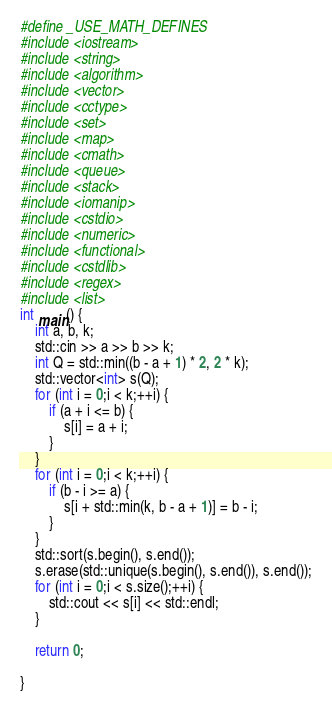Convert code to text. <code><loc_0><loc_0><loc_500><loc_500><_C++_>#define _USE_MATH_DEFINES
#include <iostream>
#include <string>
#include <algorithm>
#include <vector>
#include <cctype>
#include <set>
#include <map>
#include <cmath>
#include <queue>
#include <stack>
#include <iomanip>
#include <cstdio>
#include <numeric>
#include <functional>
#include <cstdlib>
#include <regex>
#include <list>
int main() {
	int a, b, k;
	std::cin >> a >> b >> k;
	int Q = std::min((b - a + 1) * 2, 2 * k);
	std::vector<int> s(Q);
	for (int i = 0;i < k;++i) {
		if (a + i <= b) {
			s[i] = a + i;
		}
	}
	for (int i = 0;i < k;++i) {
		if (b - i >= a) {
			s[i + std::min(k, b - a + 1)] = b - i;
		}
	}
	std::sort(s.begin(), s.end());
	s.erase(std::unique(s.begin(), s.end()), s.end());
	for (int i = 0;i < s.size();++i) {
		std::cout << s[i] << std::endl;
	}

	return 0;

}
</code> 